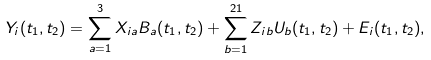Convert formula to latex. <formula><loc_0><loc_0><loc_500><loc_500>Y _ { i } ( t _ { 1 } , t _ { 2 } ) = \sum _ { a = 1 } ^ { 3 } X _ { i a } B _ { a } ( t _ { 1 } , t _ { 2 } ) + \sum _ { b = 1 } ^ { 2 1 } Z _ { i b } U _ { b } ( t _ { 1 } , t _ { 2 } ) + E _ { i } ( t _ { 1 } , t _ { 2 } ) ,</formula> 